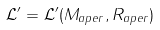<formula> <loc_0><loc_0><loc_500><loc_500>\mathcal { L ^ { \prime } } = \mathcal { L ^ { \prime } } ( M _ { a p e r } , R _ { a p e r } )</formula> 